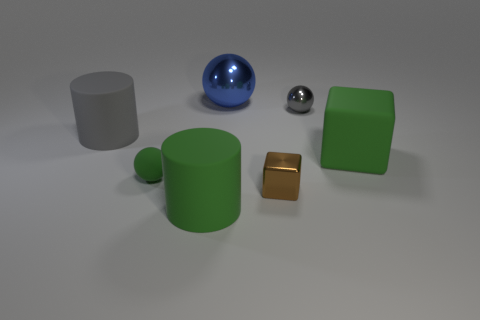There is a large object that is the same shape as the small brown thing; what is its material?
Keep it short and to the point. Rubber. There is a shiny ball that is in front of the large metal ball; what is its color?
Make the answer very short. Gray. What is the size of the green ball?
Your answer should be compact. Small. There is a shiny cube; does it have the same size as the matte cylinder that is in front of the matte sphere?
Give a very brief answer. No. What color is the cylinder that is in front of the cylinder behind the large object that is right of the gray ball?
Your answer should be compact. Green. Do the big cylinder behind the large matte block and the tiny green sphere have the same material?
Provide a succinct answer. Yes. What number of other objects are the same material as the tiny block?
Make the answer very short. 2. There is a gray object that is the same size as the green rubber ball; what is it made of?
Offer a terse response. Metal. Is the shape of the small thing in front of the rubber ball the same as the object that is right of the tiny gray shiny object?
Offer a terse response. Yes. There is a gray thing that is the same size as the blue metallic object; what is its shape?
Offer a terse response. Cylinder. 